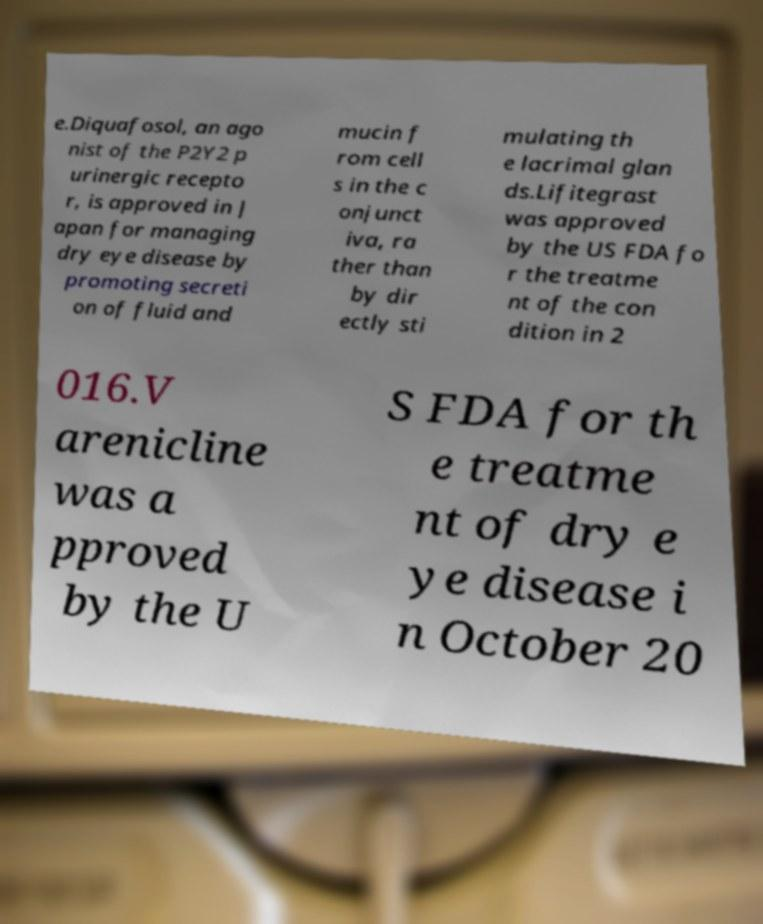For documentation purposes, I need the text within this image transcribed. Could you provide that? e.Diquafosol, an ago nist of the P2Y2 p urinergic recepto r, is approved in J apan for managing dry eye disease by promoting secreti on of fluid and mucin f rom cell s in the c onjunct iva, ra ther than by dir ectly sti mulating th e lacrimal glan ds.Lifitegrast was approved by the US FDA fo r the treatme nt of the con dition in 2 016.V arenicline was a pproved by the U S FDA for th e treatme nt of dry e ye disease i n October 20 